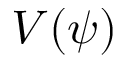<formula> <loc_0><loc_0><loc_500><loc_500>V ( \psi )</formula> 